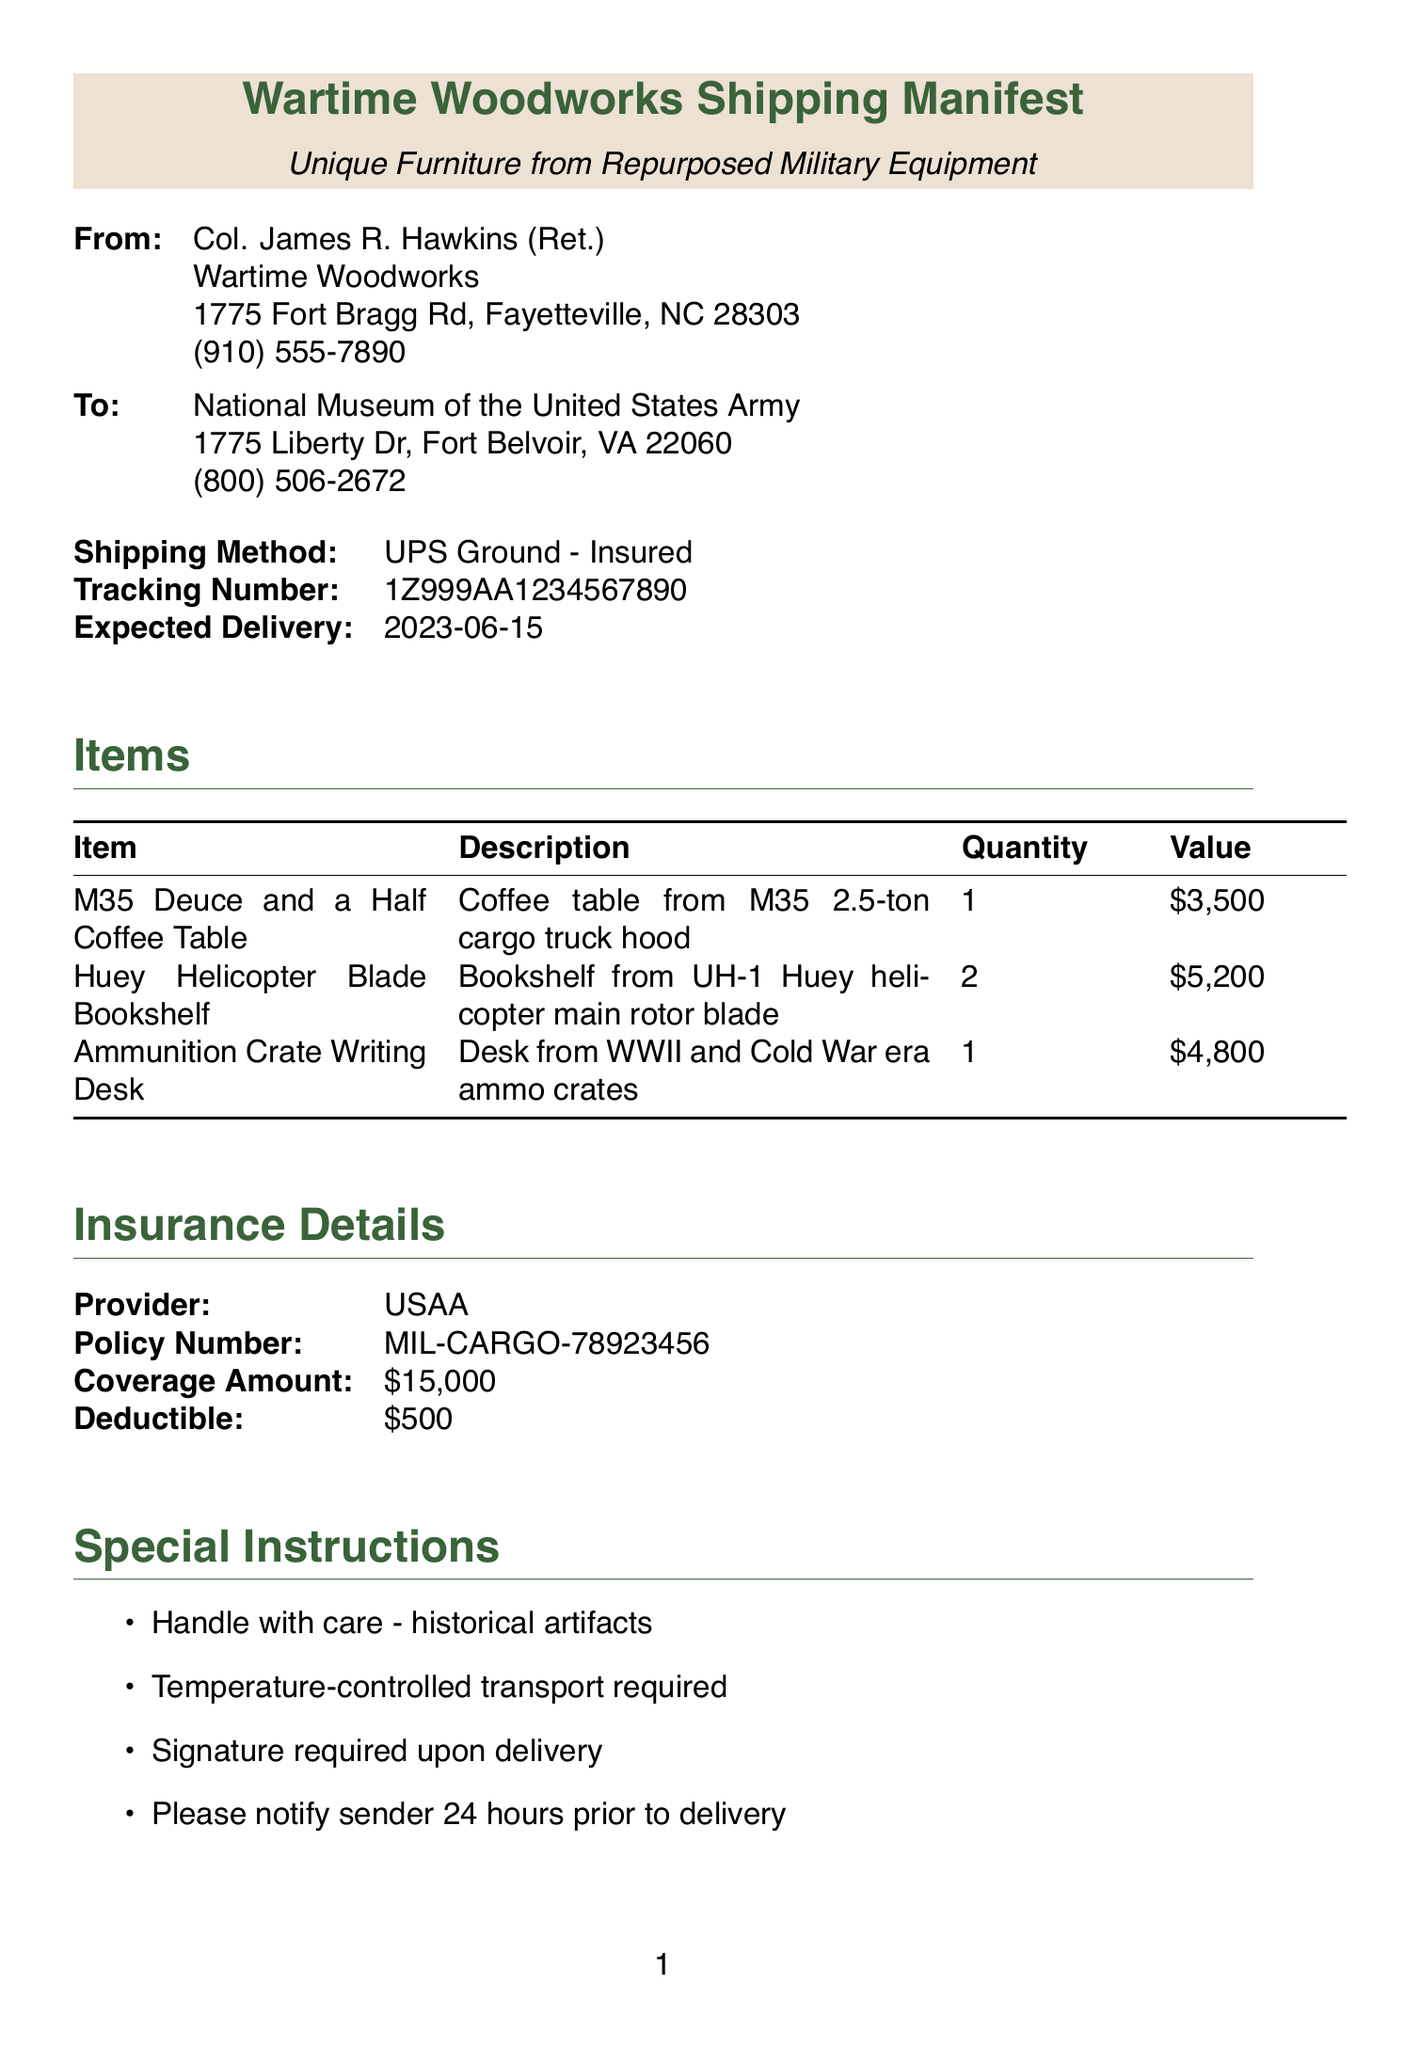What is the name of the sender? The sender's name is listed at the top of the document.
Answer: Col. James R. Hawkins (Ret.) What is the value of the Huey Helicopter Blade Bookshelf? The value is provided in the item list section of the document.
Answer: $5200 What is the shipping method used for this delivery? The shipping method is indicated in the shipment details section.
Answer: UPS Ground - Insured How many items are included in the shipment? The total number of items can be calculated from the list provided in the document.
Answer: 4 What is the expected delivery date? The expected delivery date is specified in the shipment details section.
Answer: 2023-06-15 What is the total coverage amount of the insurance? The coverage amount is indicated in the insurance details section.
Answer: $15000 Which items are constructed from military equipment? All items listed are either made from or incorporate military equipment as stated in their descriptions.
Answer: M35 Deuce and a Half Coffee Table, Huey Helicopter Blade Bookshelf, Ammunition Crate Writing Desk What type of items are being shipped? The document explicitly states that all items are furniture made from repurposed military equipment.
Answer: Unique furniture What must be done 24 hours prior to delivery? Special instructions state specific actions required before delivery.
Answer: Notify sender 